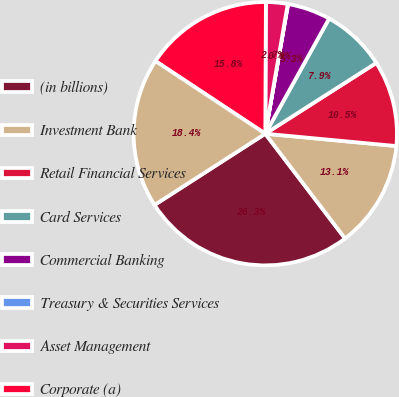<chart> <loc_0><loc_0><loc_500><loc_500><pie_chart><fcel>(in billions)<fcel>Investment Bank<fcel>Retail Financial Services<fcel>Card Services<fcel>Commercial Banking<fcel>Treasury & Securities Services<fcel>Asset Management<fcel>Corporate (a)<fcel>Total common stockholders'<nl><fcel>26.26%<fcel>13.15%<fcel>10.53%<fcel>7.91%<fcel>5.28%<fcel>0.04%<fcel>2.66%<fcel>15.77%<fcel>18.4%<nl></chart> 